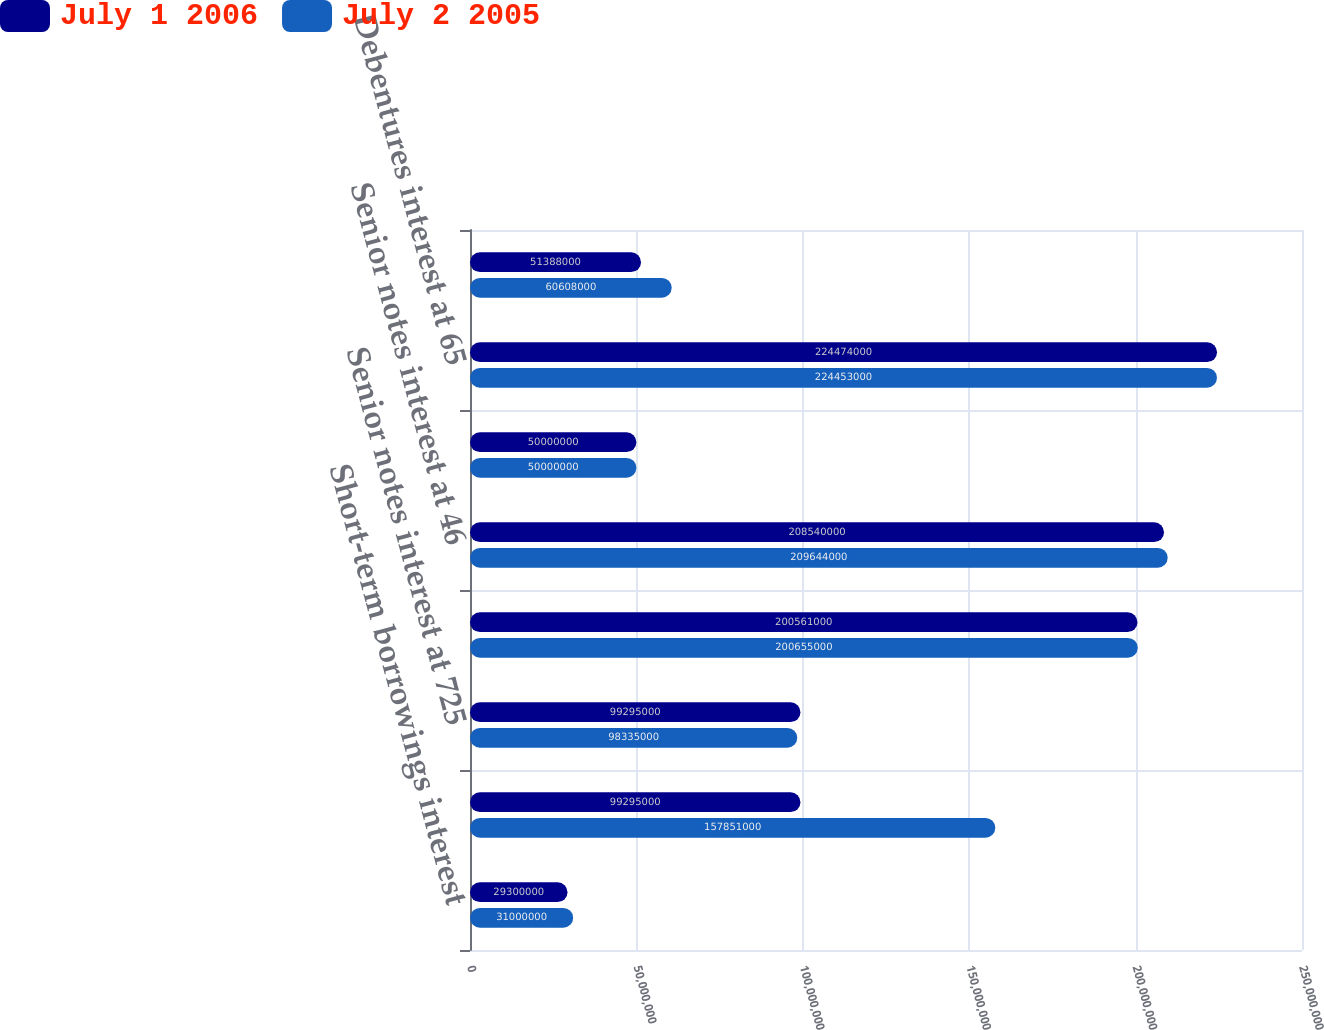<chart> <loc_0><loc_0><loc_500><loc_500><stacked_bar_chart><ecel><fcel>Short-term borrowings interest<fcel>Commercial paper interest<fcel>Senior notes interest at 725<fcel>Senior notes interest at 61<fcel>Senior notes interest at 46<fcel>Debentures interest at 716<fcel>Debentures interest at 65<fcel>Industrial Revenue Bonds<nl><fcel>July 1 2006<fcel>2.93e+07<fcel>9.9295e+07<fcel>9.9295e+07<fcel>2.00561e+08<fcel>2.0854e+08<fcel>5e+07<fcel>2.24474e+08<fcel>5.1388e+07<nl><fcel>July 2 2005<fcel>3.1e+07<fcel>1.57851e+08<fcel>9.8335e+07<fcel>2.00655e+08<fcel>2.09644e+08<fcel>5e+07<fcel>2.24453e+08<fcel>6.0608e+07<nl></chart> 